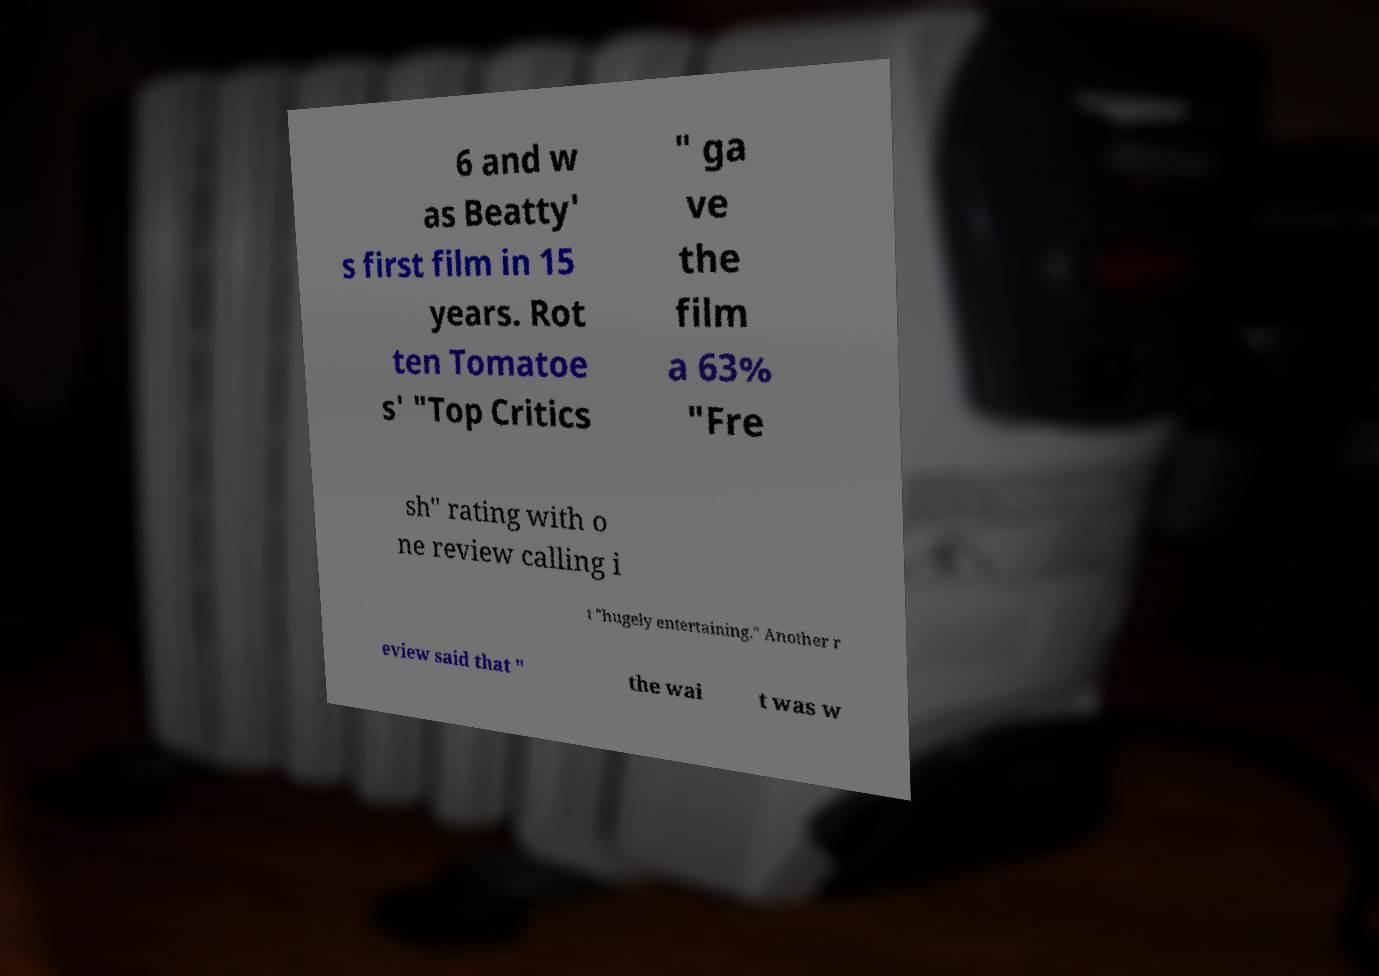What messages or text are displayed in this image? I need them in a readable, typed format. 6 and w as Beatty' s first film in 15 years. Rot ten Tomatoe s' "Top Critics " ga ve the film a 63% "Fre sh" rating with o ne review calling i t "hugely entertaining." Another r eview said that " the wai t was w 